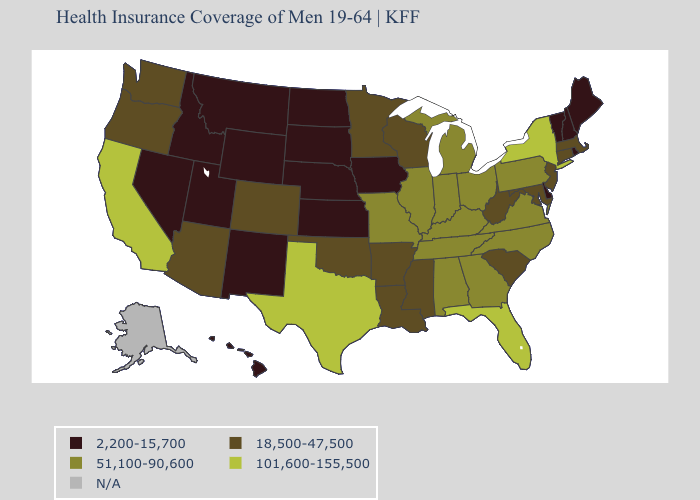Among the states that border Connecticut , which have the highest value?
Quick response, please. New York. What is the lowest value in the South?
Give a very brief answer. 2,200-15,700. Name the states that have a value in the range 2,200-15,700?
Give a very brief answer. Delaware, Hawaii, Idaho, Iowa, Kansas, Maine, Montana, Nebraska, Nevada, New Hampshire, New Mexico, North Dakota, Rhode Island, South Dakota, Utah, Vermont, Wyoming. Among the states that border Arizona , does Colorado have the lowest value?
Write a very short answer. No. Among the states that border Michigan , which have the highest value?
Give a very brief answer. Indiana, Ohio. Name the states that have a value in the range 51,100-90,600?
Give a very brief answer. Alabama, Georgia, Illinois, Indiana, Kentucky, Michigan, Missouri, North Carolina, Ohio, Pennsylvania, Tennessee, Virginia. What is the value of New Hampshire?
Short answer required. 2,200-15,700. How many symbols are there in the legend?
Quick response, please. 5. Which states have the lowest value in the MidWest?
Short answer required. Iowa, Kansas, Nebraska, North Dakota, South Dakota. Which states hav the highest value in the South?
Answer briefly. Florida, Texas. What is the value of New Jersey?
Concise answer only. 18,500-47,500. Name the states that have a value in the range 18,500-47,500?
Keep it brief. Arizona, Arkansas, Colorado, Connecticut, Louisiana, Maryland, Massachusetts, Minnesota, Mississippi, New Jersey, Oklahoma, Oregon, South Carolina, Washington, West Virginia, Wisconsin. What is the value of Montana?
Quick response, please. 2,200-15,700. 